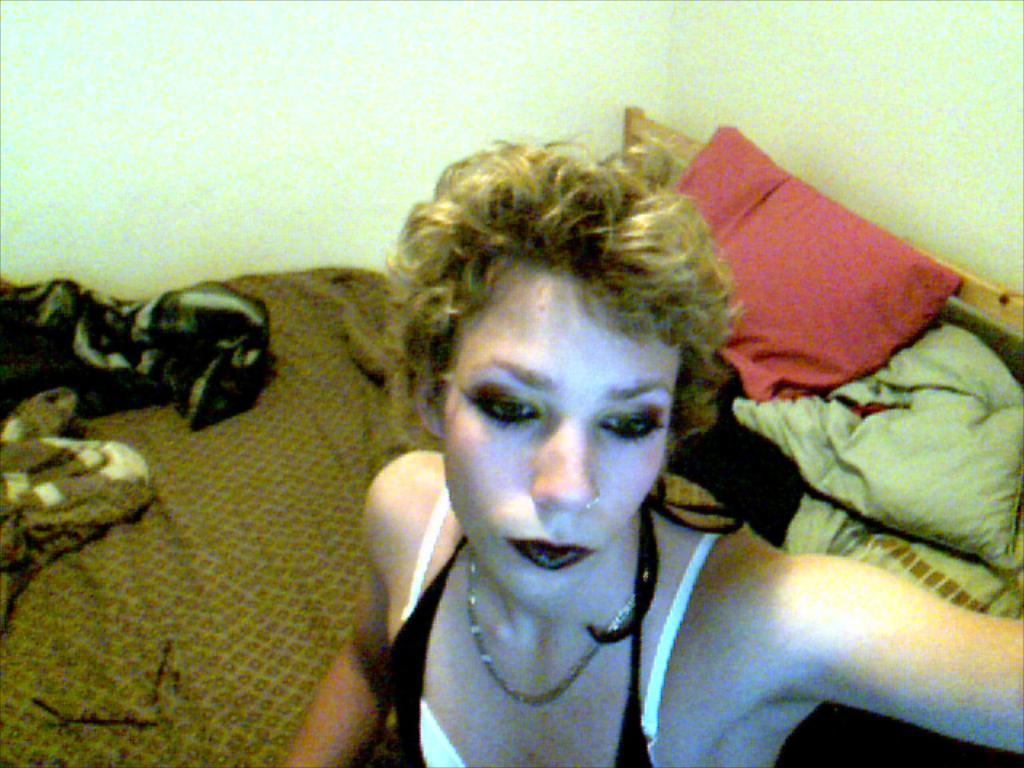Who is present in the image? There is a woman in the image. What is the woman doing in the image? The woman is sitting on a bed. What can be seen on the bed besides the woman? There are bed sheets and pillows on the bed. What is visible behind the bed? There is a wall behind the bed. What type of baseball equipment can be seen in the image? There is no baseball equipment present in the image. What is the woman cooking on the oven in the image? There is no oven or cooking activity present in the image. 